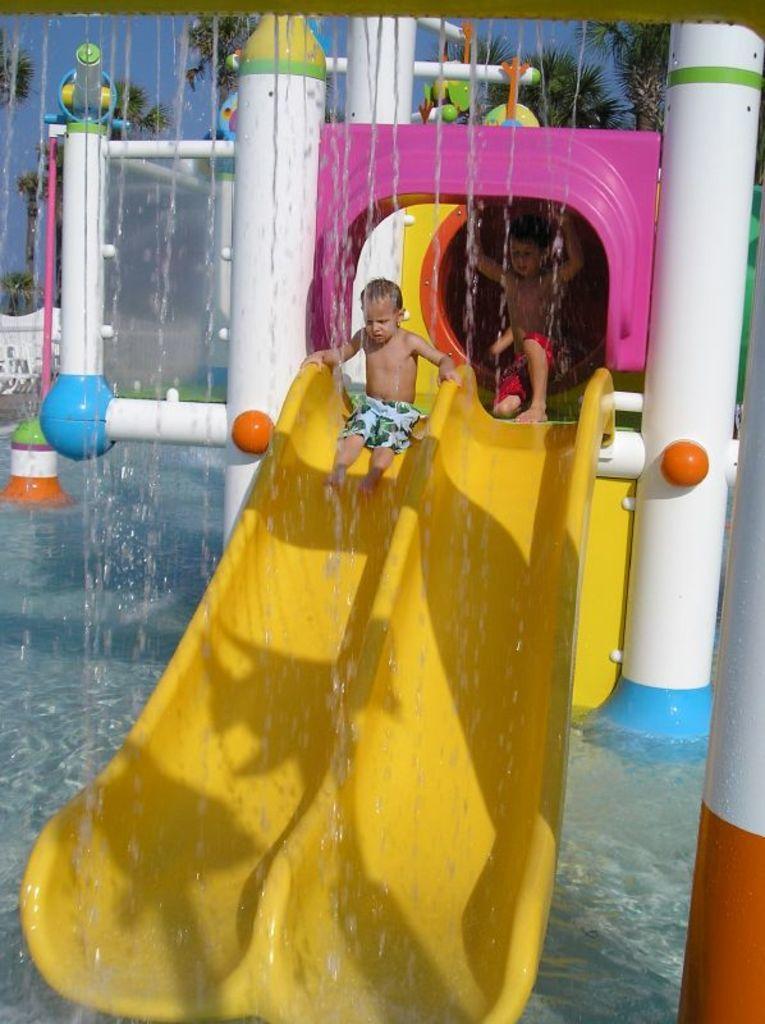How would you summarize this image in a sentence or two? A child is sliding another child is sitting, this is water, these are trees. 